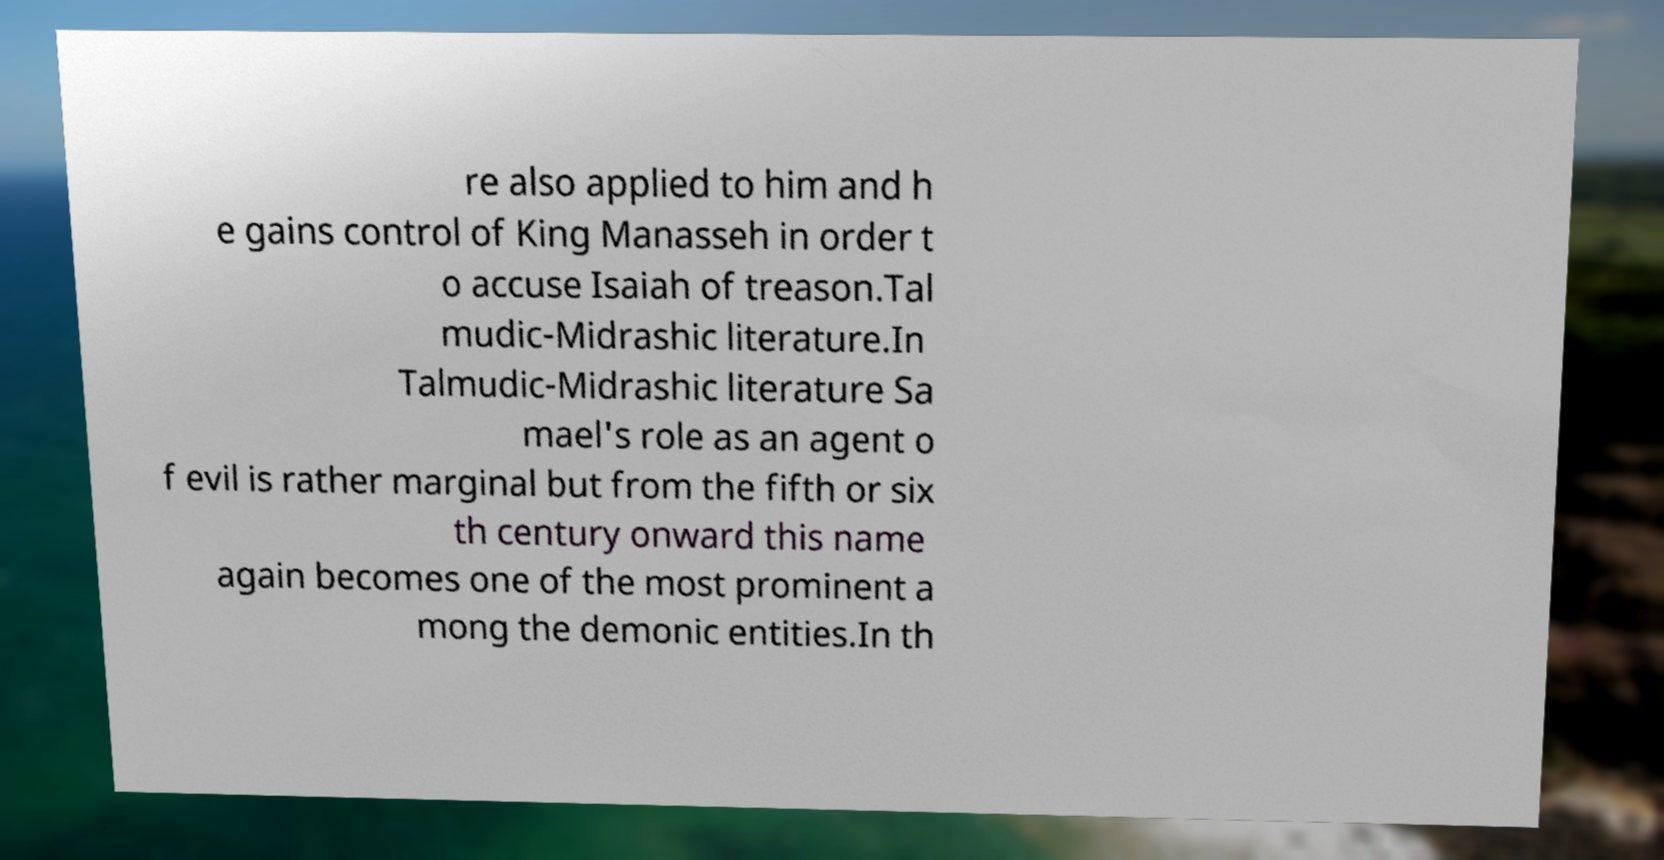For documentation purposes, I need the text within this image transcribed. Could you provide that? re also applied to him and h e gains control of King Manasseh in order t o accuse Isaiah of treason.Tal mudic-Midrashic literature.In Talmudic-Midrashic literature Sa mael's role as an agent o f evil is rather marginal but from the fifth or six th century onward this name again becomes one of the most prominent a mong the demonic entities.In th 